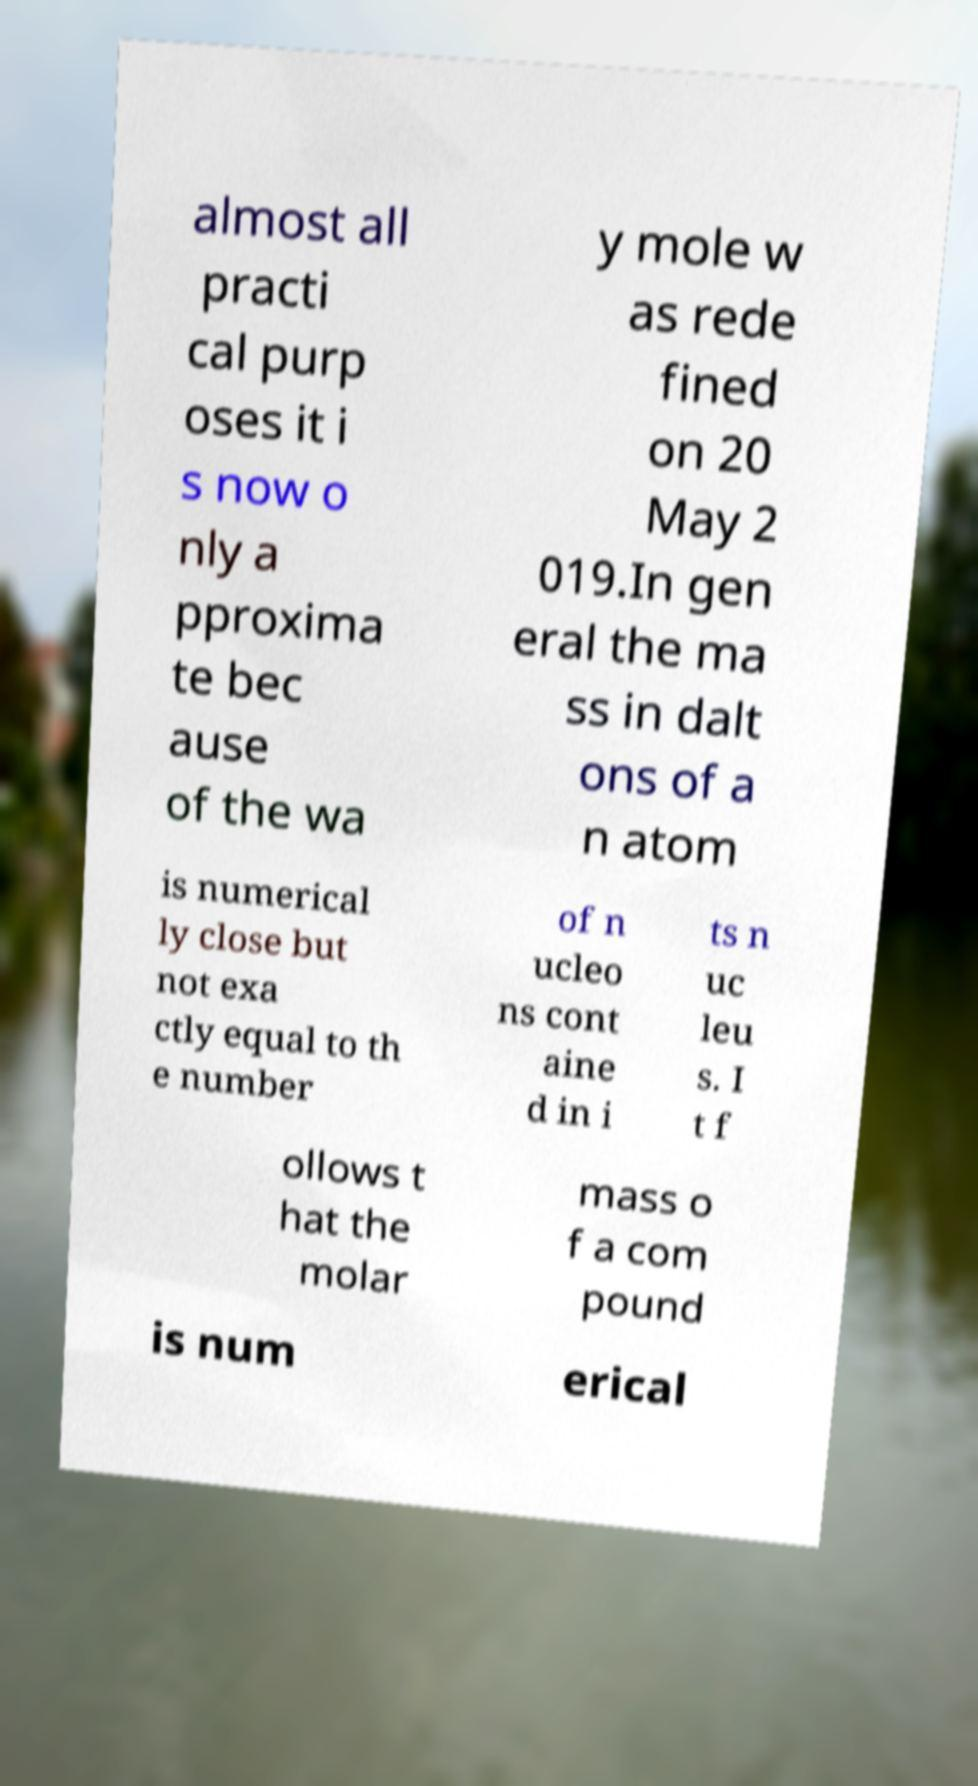There's text embedded in this image that I need extracted. Can you transcribe it verbatim? almost all practi cal purp oses it i s now o nly a pproxima te bec ause of the wa y mole w as rede fined on 20 May 2 019.In gen eral the ma ss in dalt ons of a n atom is numerical ly close but not exa ctly equal to th e number of n ucleo ns cont aine d in i ts n uc leu s. I t f ollows t hat the molar mass o f a com pound is num erical 